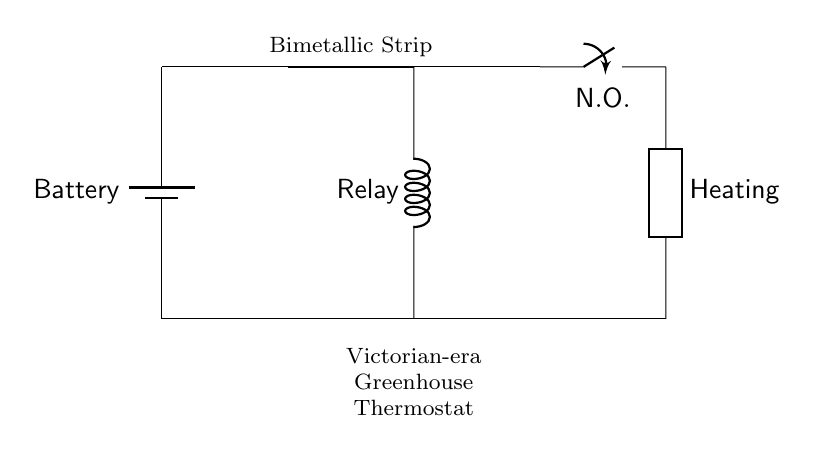What is the power source in this circuit? The power source is a battery, as indicated by the label next to the battery symbol. This identifies the component that provides electrical energy to the circuit.
Answer: Battery What component is used to sense temperature changes? The bimetallic strip is the component used for temperature sensing. It expands and contracts based on temperature changes, which allows it to control the relay in the circuit.
Answer: Bimetallic Strip What type of switch is used in this circuit? The circuit uses a normally open (N.O.) switch as indicated by the label on the switch symbol. This means that the switch remains open until activated by the bimetallic strip through the relay.
Answer: Normally Open How does the bimetallic strip influence the relay? The bimetallic strip bends with temperature changes, closing the circuit to the relay when a certain temperature is reached. This energizes the relay, allowing it to close the switch and activate the heating element.
Answer: It closes the circuit to the relay What is the function of the heating element? The heating element's function is to provide heat to the greenhouse when activated by the relay. This helps maintain the proper temperature for plant growth in the greenhouse environment.
Answer: Provide heat What happens when the temperature exceeds the set point? When the temperature exceeds the set point, the bimetallic strip bends, closing the relay circuit, which activates the normally open switch, allowing current to flow through the heating element.
Answer: The heating element turns on 